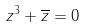<formula> <loc_0><loc_0><loc_500><loc_500>z ^ { 3 } + \overline { z } = 0</formula> 